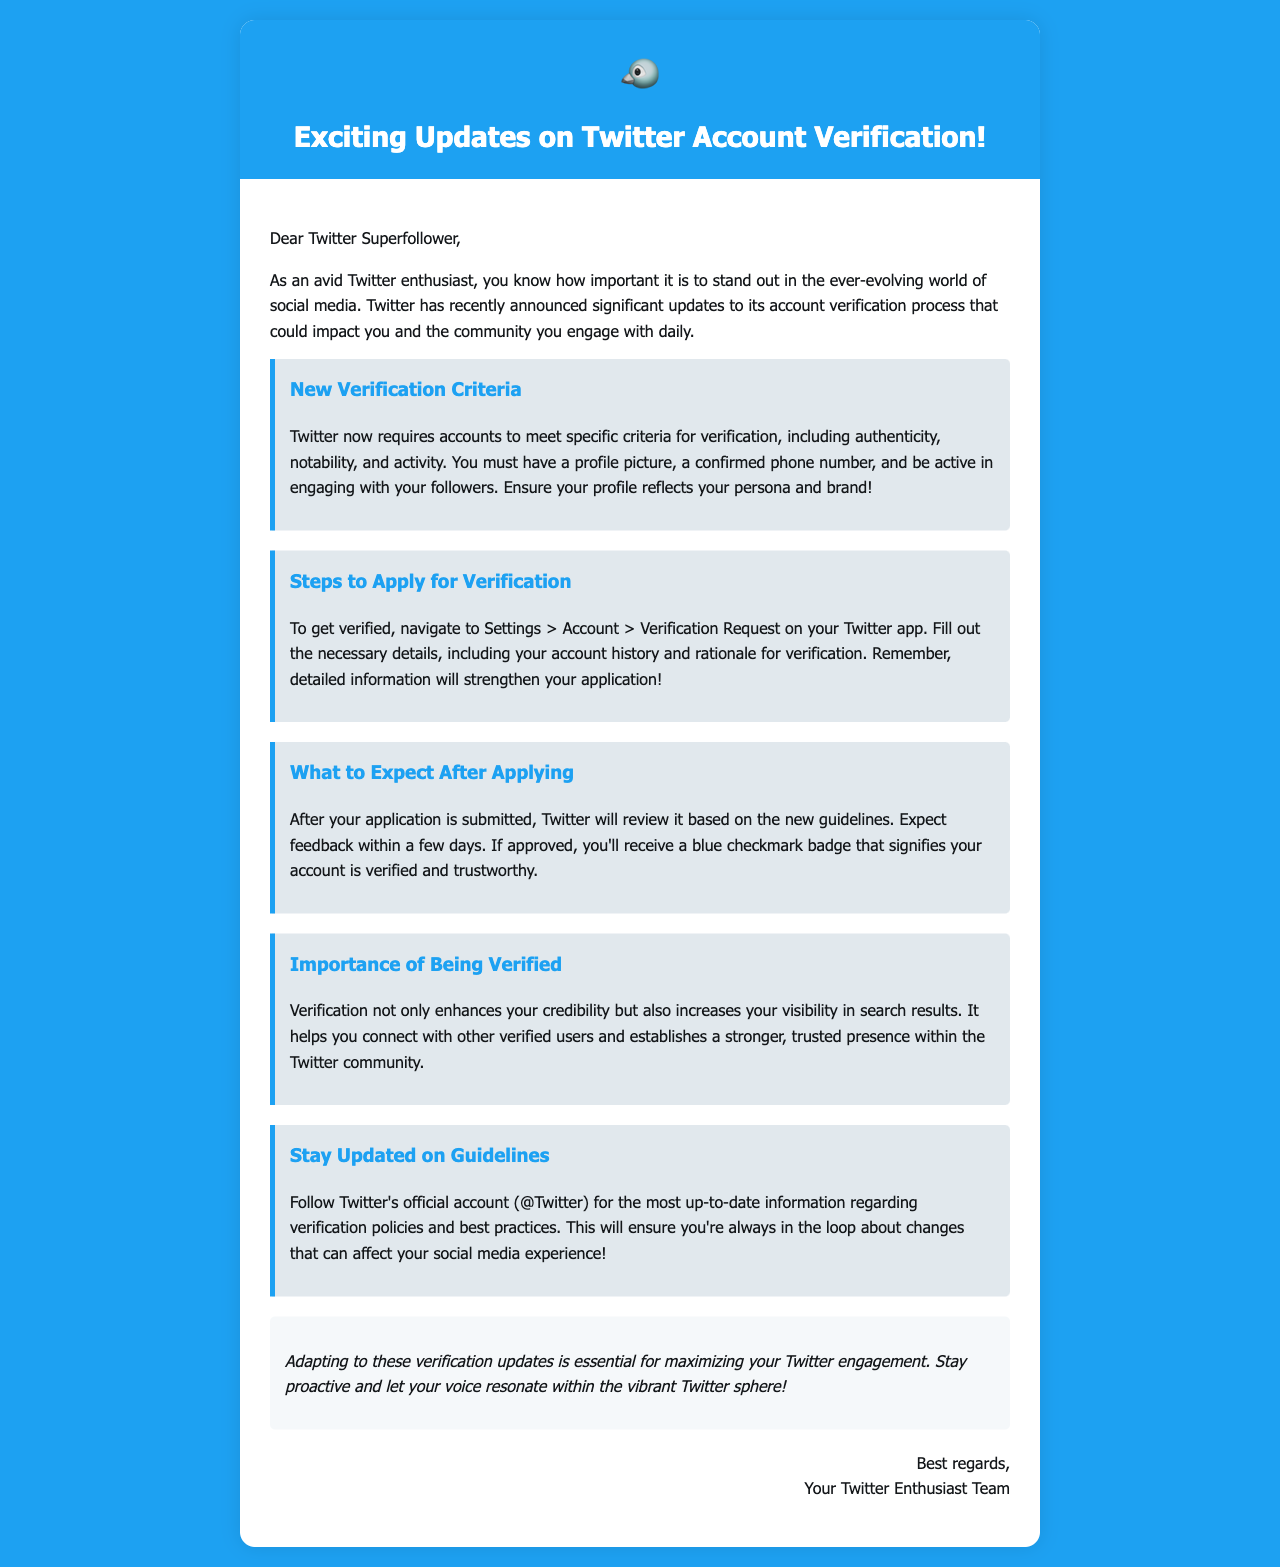What are the new verification criteria? The document states that accounts need to meet criteria including authenticity, notability, and activity for verification.
Answer: authenticity, notability, activity Where can I apply for verification? According to the document, you should navigate to Settings > Account > Verification Request to apply for verification.
Answer: Settings > Account > Verification Request How long does it take to get feedback after applying? The document mentions that you can expect feedback within a few days after submission of the application.
Answer: a few days What benefits come from being verified? The document highlights that verification enhances credibility and increases visibility in search results.
Answer: enhances credibility, increases visibility Which account should you follow for updates on verification policies? The document instructs readers to follow Twitter's official account for the latest information on verification policies.
Answer: @Twitter 